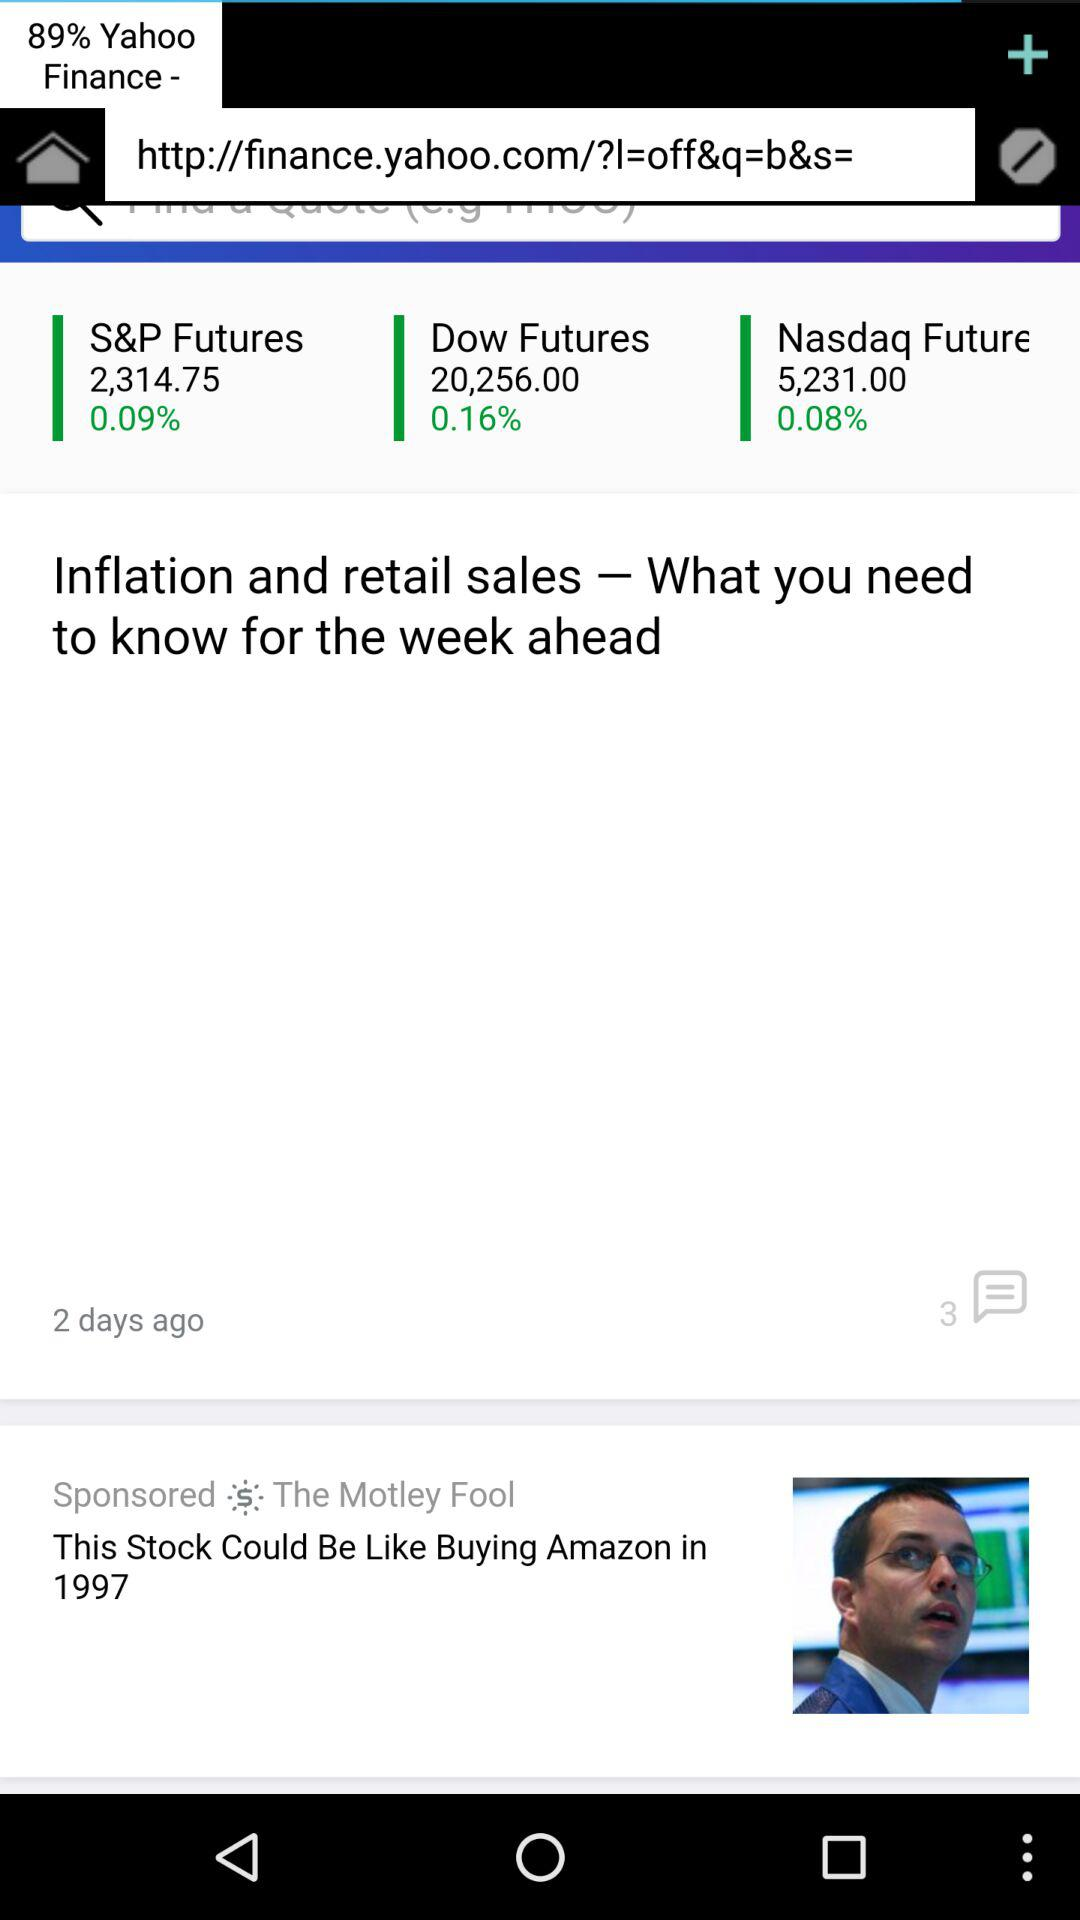What is the given percentage of Dow Futures? The given percentage is 0.16. 